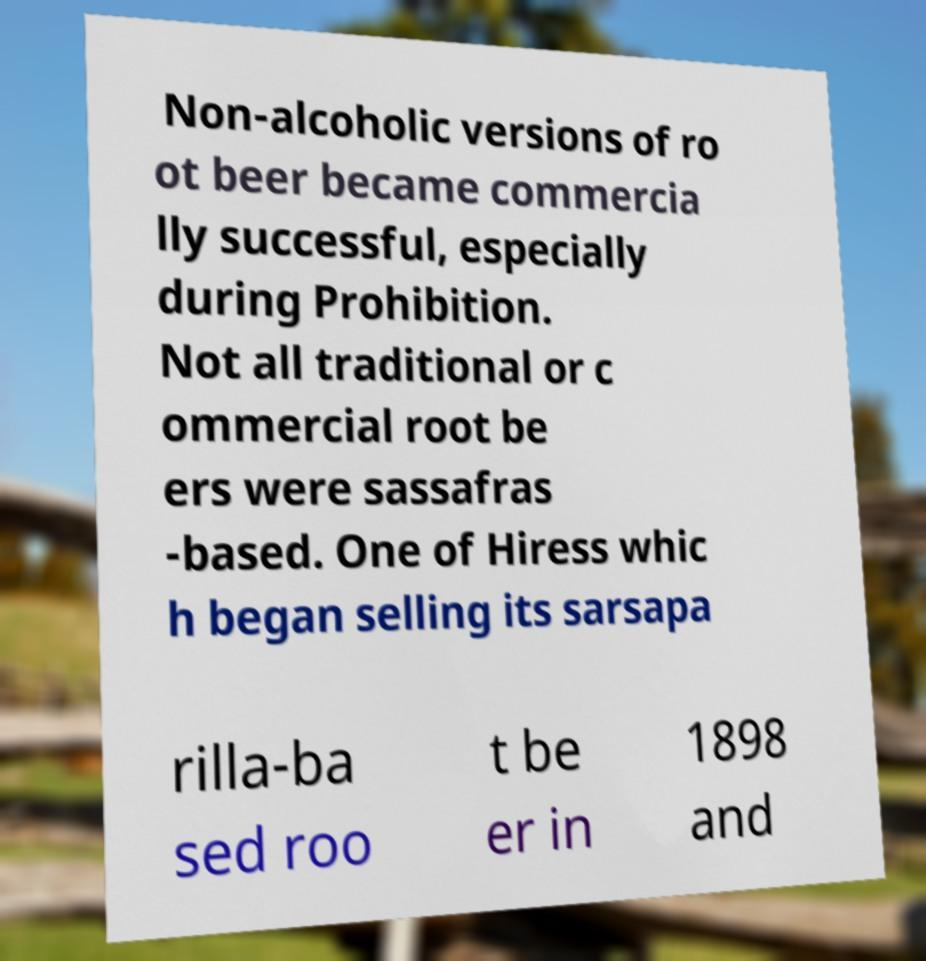I need the written content from this picture converted into text. Can you do that? Non-alcoholic versions of ro ot beer became commercia lly successful, especially during Prohibition. Not all traditional or c ommercial root be ers were sassafras -based. One of Hiress whic h began selling its sarsapa rilla-ba sed roo t be er in 1898 and 